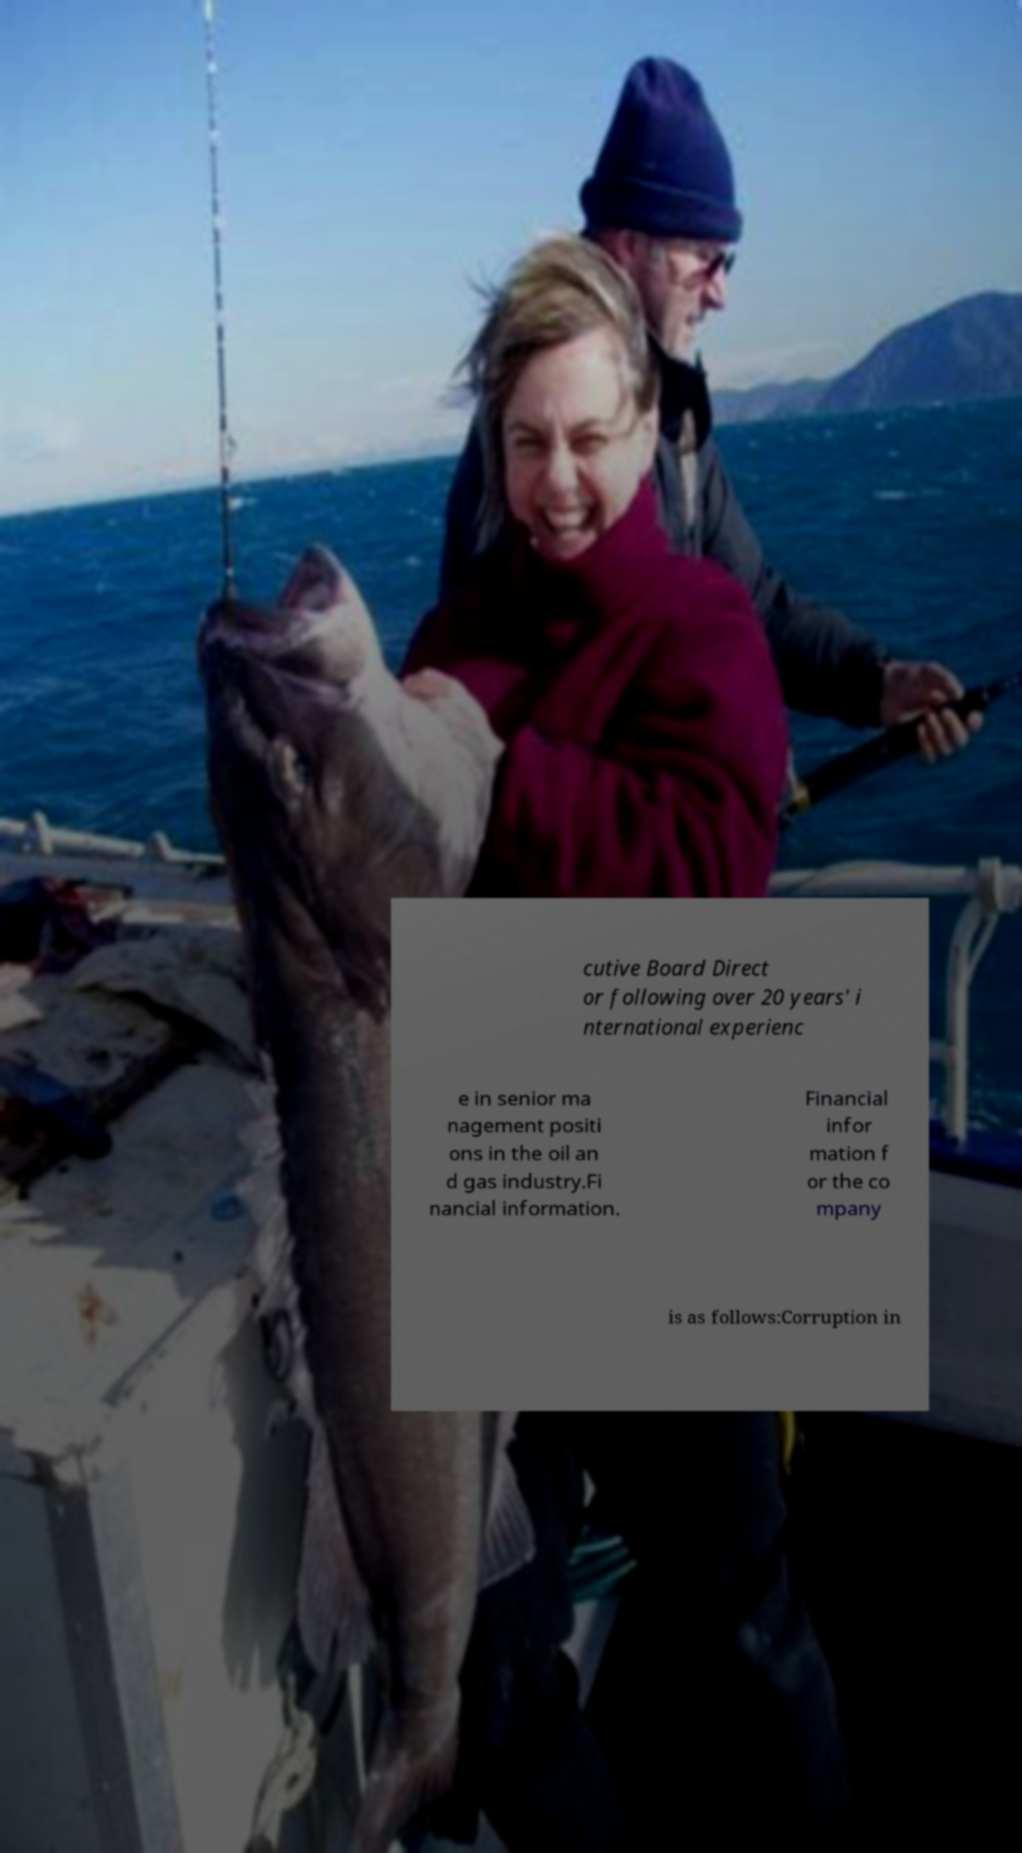What messages or text are displayed in this image? I need them in a readable, typed format. cutive Board Direct or following over 20 years' i nternational experienc e in senior ma nagement positi ons in the oil an d gas industry.Fi nancial information. Financial infor mation f or the co mpany is as follows:Corruption in 